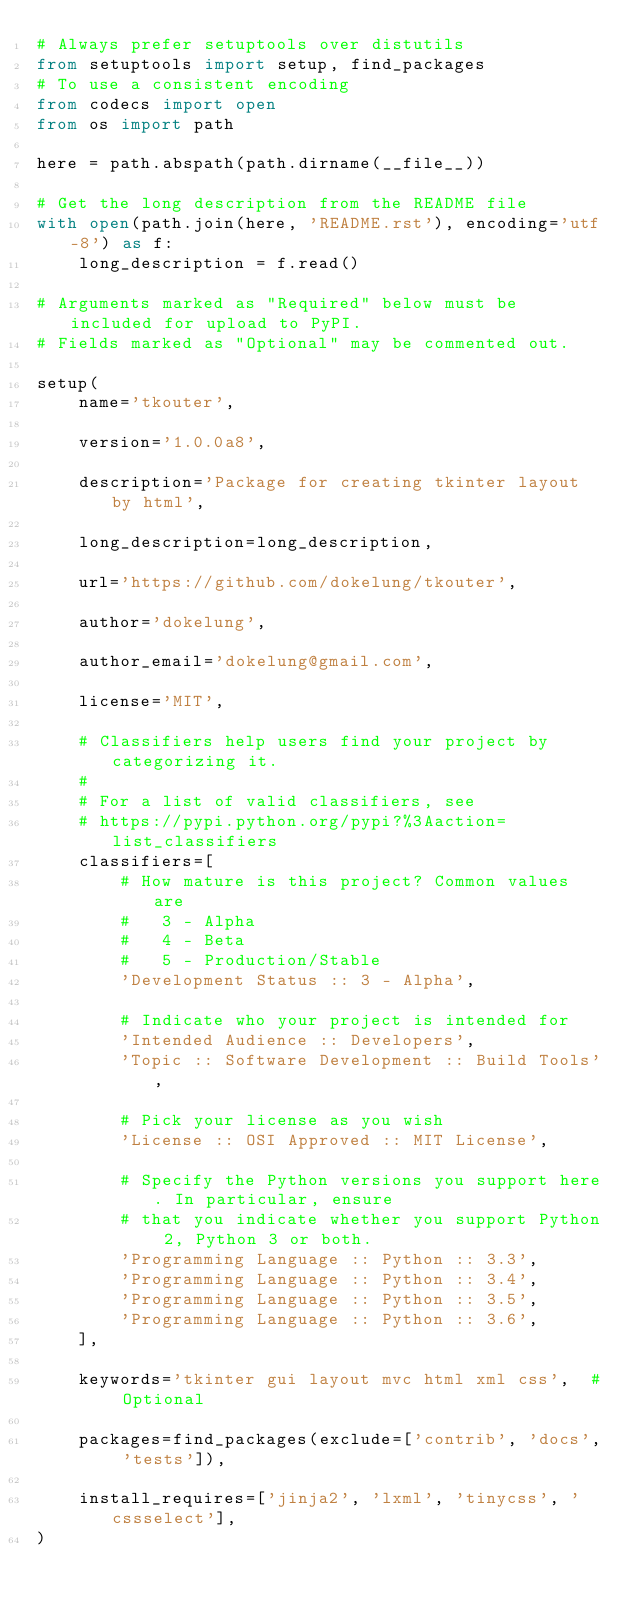<code> <loc_0><loc_0><loc_500><loc_500><_Python_># Always prefer setuptools over distutils
from setuptools import setup, find_packages
# To use a consistent encoding
from codecs import open
from os import path

here = path.abspath(path.dirname(__file__))

# Get the long description from the README file
with open(path.join(here, 'README.rst'), encoding='utf-8') as f:
    long_description = f.read()

# Arguments marked as "Required" below must be included for upload to PyPI.
# Fields marked as "Optional" may be commented out.

setup(
    name='tkouter',

    version='1.0.0a8',

    description='Package for creating tkinter layout by html',

    long_description=long_description,

    url='https://github.com/dokelung/tkouter',

    author='dokelung',

    author_email='dokelung@gmail.com',

    license='MIT',

    # Classifiers help users find your project by categorizing it.
    #
    # For a list of valid classifiers, see
    # https://pypi.python.org/pypi?%3Aaction=list_classifiers
    classifiers=[
        # How mature is this project? Common values are
        #   3 - Alpha
        #   4 - Beta
        #   5 - Production/Stable
        'Development Status :: 3 - Alpha',

        # Indicate who your project is intended for
        'Intended Audience :: Developers',
        'Topic :: Software Development :: Build Tools',

        # Pick your license as you wish
        'License :: OSI Approved :: MIT License',

        # Specify the Python versions you support here. In particular, ensure
        # that you indicate whether you support Python 2, Python 3 or both.
        'Programming Language :: Python :: 3.3',
        'Programming Language :: Python :: 3.4',
        'Programming Language :: Python :: 3.5',
        'Programming Language :: Python :: 3.6',
    ],

    keywords='tkinter gui layout mvc html xml css',  # Optional

    packages=find_packages(exclude=['contrib', 'docs', 'tests']),

    install_requires=['jinja2', 'lxml', 'tinycss', 'cssselect'],
)
</code> 